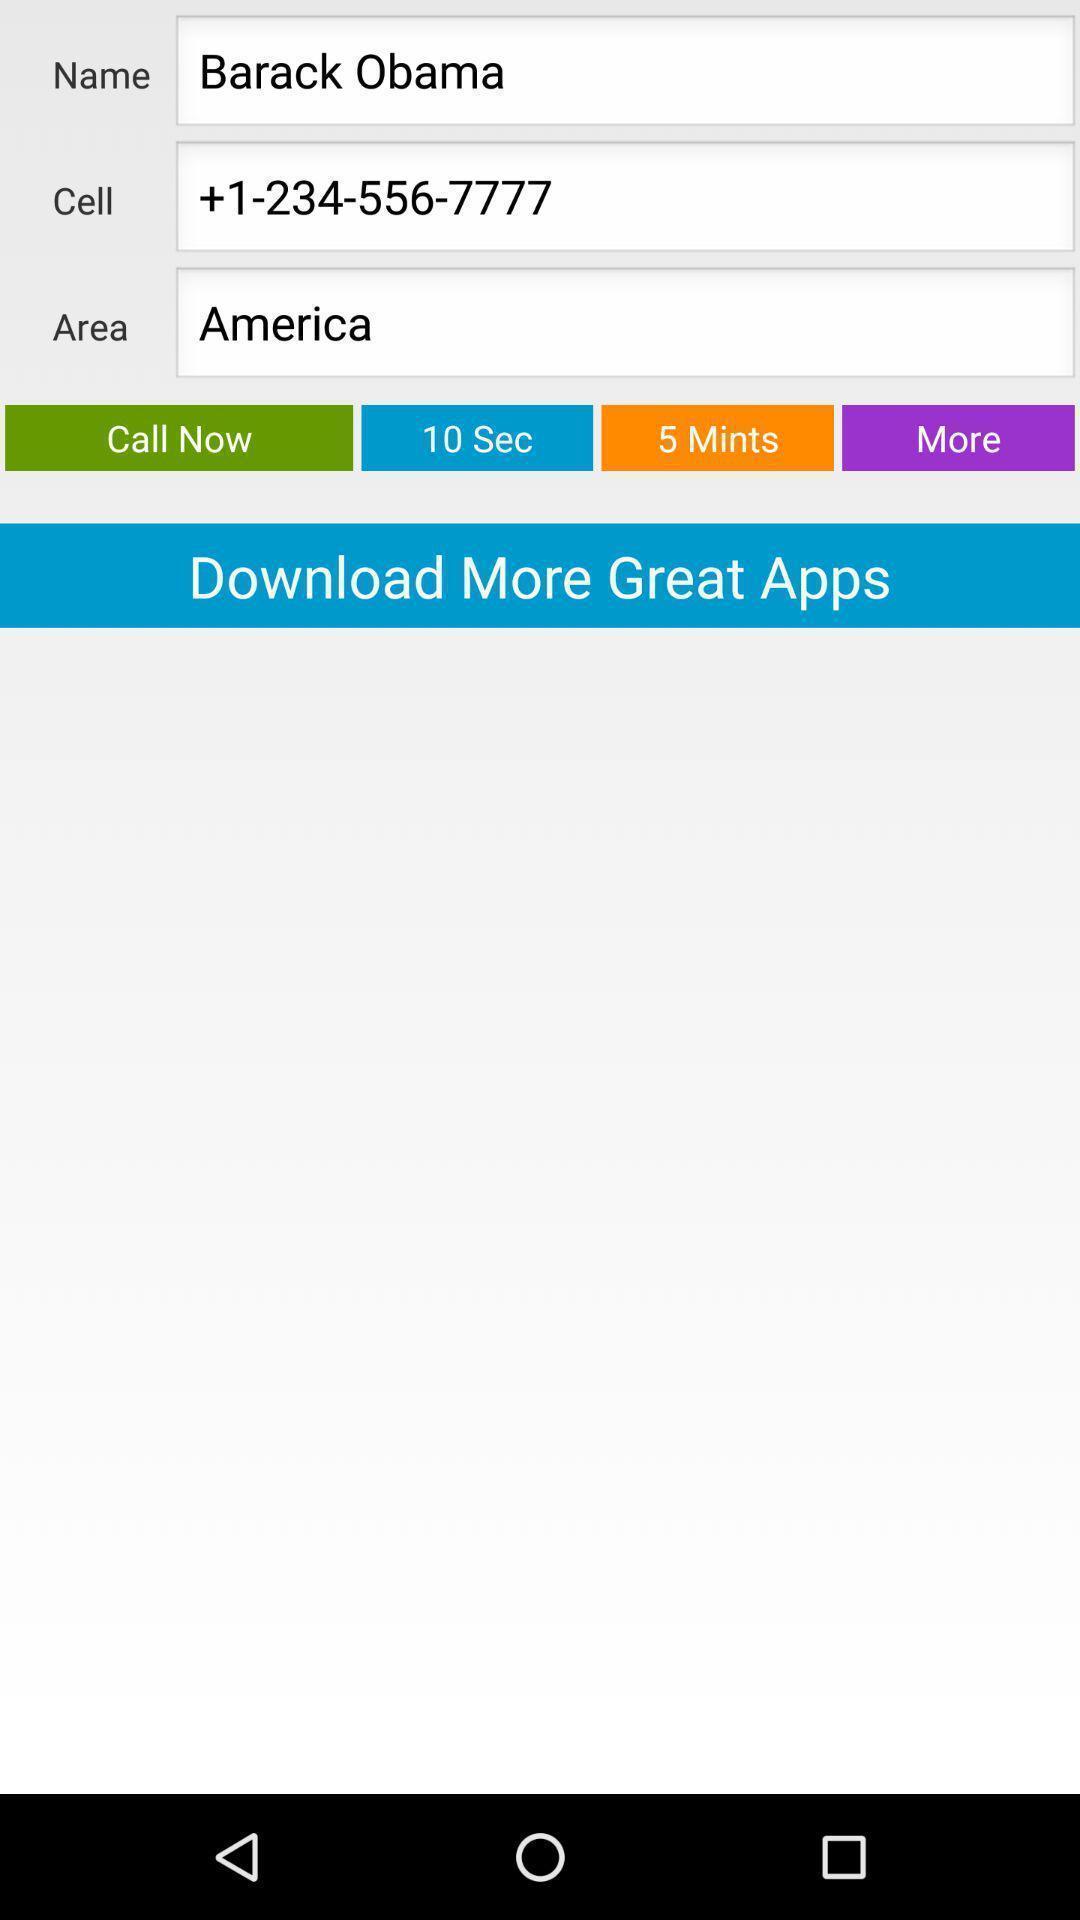Give me a narrative description of this picture. Screen displaying adding details for reminder to call. 